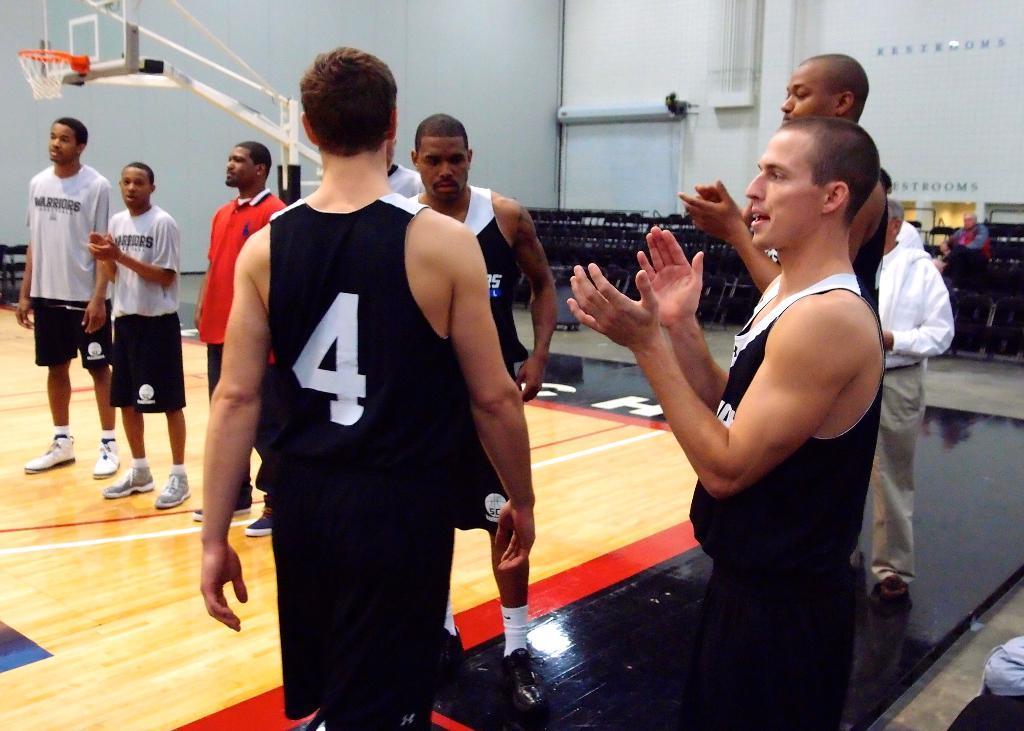Describe this image in one or two sentences. In the foreground of this image, there are four men in black T shirts are standing on the basketball court. On the right, the two men are clapping their hands. In the background, there are few persons standing on the court, a basket ball pole, wall and the black chairs. 